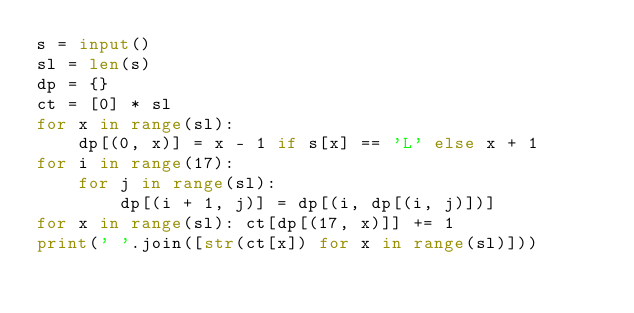Convert code to text. <code><loc_0><loc_0><loc_500><loc_500><_Python_>s = input()
sl = len(s)
dp = {}
ct = [0] * sl
for x in range(sl):
    dp[(0, x)] = x - 1 if s[x] == 'L' else x + 1
for i in range(17):
    for j in range(sl):
        dp[(i + 1, j)] = dp[(i, dp[(i, j)])]
for x in range(sl): ct[dp[(17, x)]] += 1
print(' '.join([str(ct[x]) for x in range(sl)]))</code> 